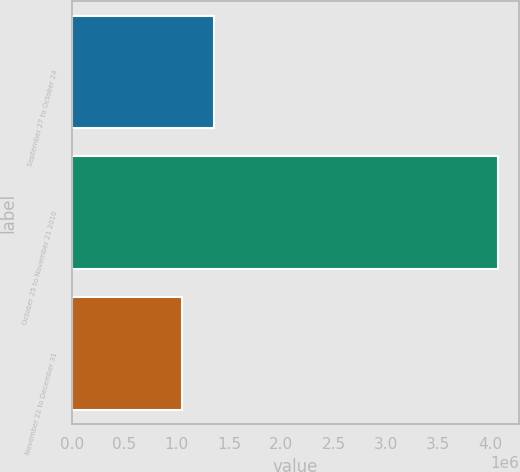Convert chart to OTSL. <chart><loc_0><loc_0><loc_500><loc_500><bar_chart><fcel>September 27 to October 24<fcel>October 25 to November 21 2010<fcel>November 22 to December 31<nl><fcel>1.35704e+06<fcel>4.07026e+06<fcel>1.05558e+06<nl></chart> 